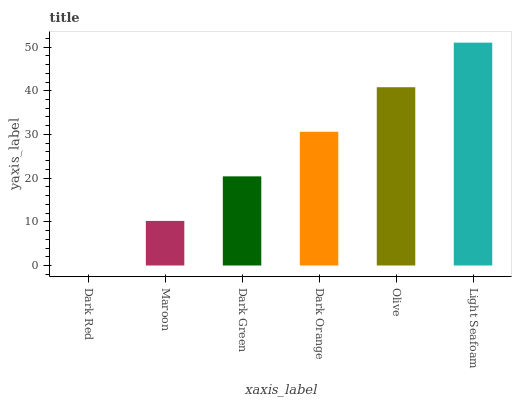Is Dark Red the minimum?
Answer yes or no. Yes. Is Light Seafoam the maximum?
Answer yes or no. Yes. Is Maroon the minimum?
Answer yes or no. No. Is Maroon the maximum?
Answer yes or no. No. Is Maroon greater than Dark Red?
Answer yes or no. Yes. Is Dark Red less than Maroon?
Answer yes or no. Yes. Is Dark Red greater than Maroon?
Answer yes or no. No. Is Maroon less than Dark Red?
Answer yes or no. No. Is Dark Orange the high median?
Answer yes or no. Yes. Is Dark Green the low median?
Answer yes or no. Yes. Is Maroon the high median?
Answer yes or no. No. Is Olive the low median?
Answer yes or no. No. 